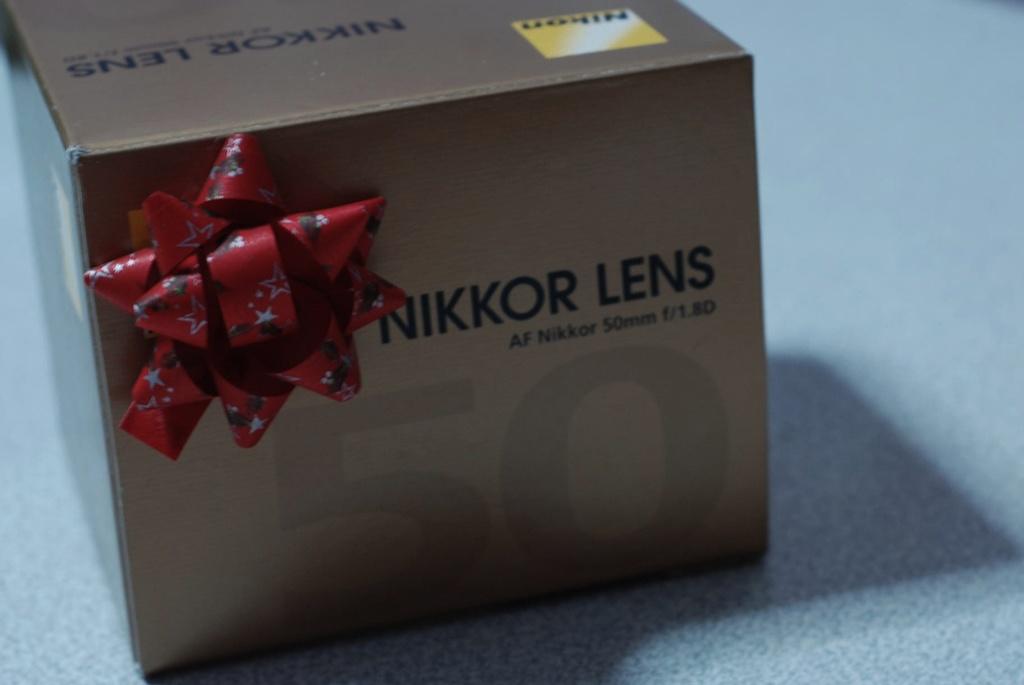What kind of lens is this?
Keep it short and to the point. Nikkor. 